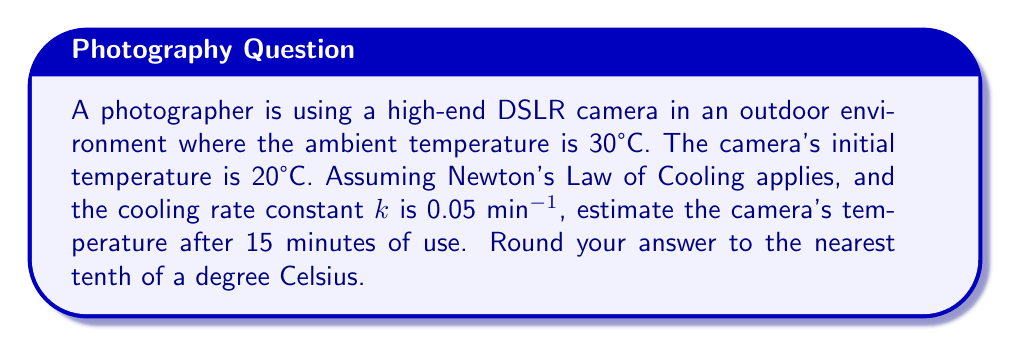Solve this math problem. To solve this problem, we'll use Newton's Law of Cooling:

$$T(t) = T_s + (T_0 - T_s)e^{-kt}$$

Where:
$T(t)$ is the temperature at time $t$
$T_s$ is the surrounding temperature (30°C)
$T_0$ is the initial temperature of the camera (20°C)
$k$ is the cooling rate constant (0.05 min^(-1))
$t$ is the time elapsed (15 minutes)

Step 1: Substitute the known values into the equation:
$$T(15) = 30 + (20 - 30)e^{-0.05 \cdot 15}$$

Step 2: Simplify the expression inside the parentheses:
$$T(15) = 30 + (-10)e^{-0.05 \cdot 15}$$

Step 3: Calculate the exponent:
$$-0.05 \cdot 15 = -0.75$$

Step 4: Evaluate the exponential term:
$$e^{-0.75} \approx 0.4724$$

Step 5: Multiply the result by -10:
$$-10 \cdot 0.4724 \approx -4.724$$

Step 6: Add this result to 30:
$$30 + (-4.724) \approx 25.276$$

Step 7: Round to the nearest tenth:
$$25.3°C$$
Answer: 25.3°C 